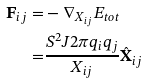Convert formula to latex. <formula><loc_0><loc_0><loc_500><loc_500>\mathbf F _ { i j } = & - \mathbf \nabla _ { X _ { i j } } E _ { t o t } \\ = & \frac { S ^ { 2 } J 2 \pi q _ { i } q _ { j } } { X _ { i j } } \hat { \mathbf X } _ { i j }</formula> 